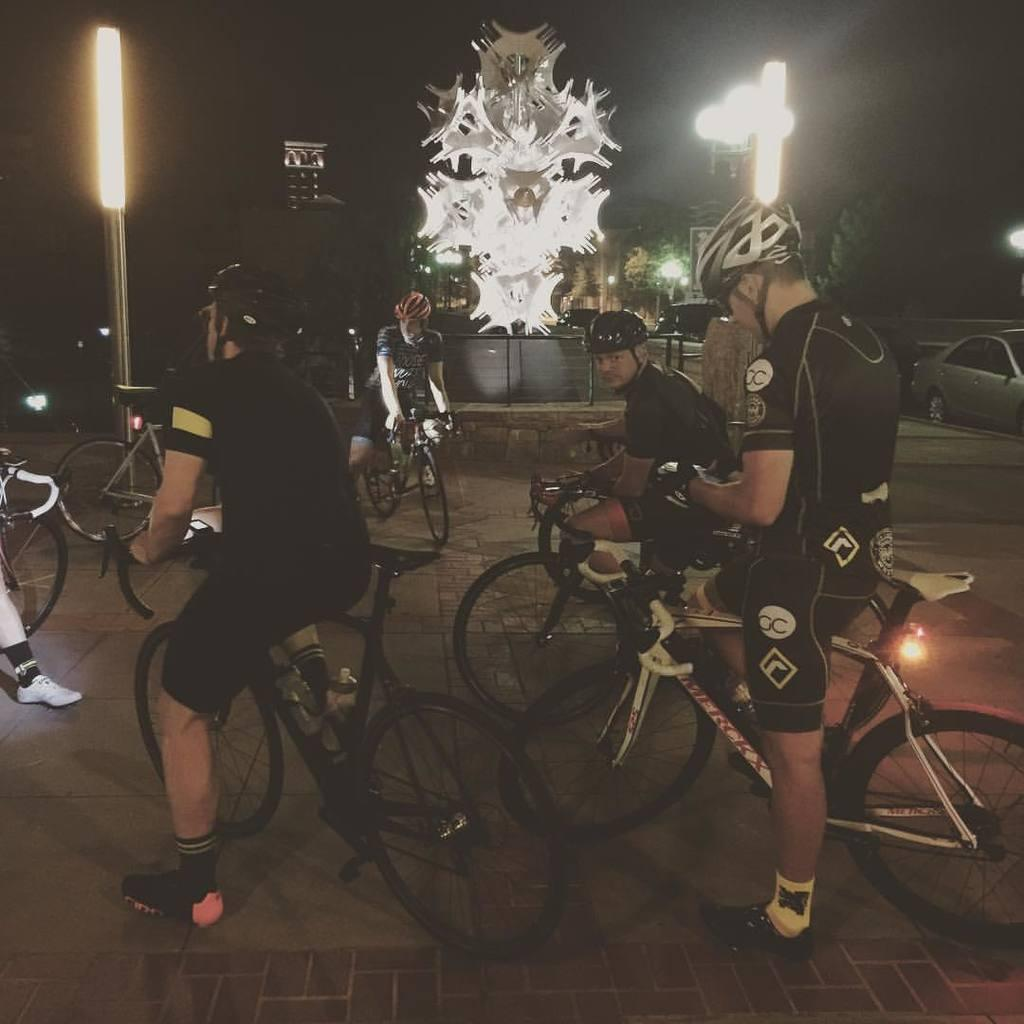What are the men in the image doing? The men in the image are sitting on bicycles. What can be seen on the poles in the image? There are lights on poles in the image. What is visible in the background of the image? There are vehicles visible in the background of the image. What type of rings can be seen on the men's fingers in the image? There are no rings visible on the men's fingers in the image. What color is the cloth draped over the bicycle in the image? There is no cloth draped over the bicycle in the image. 